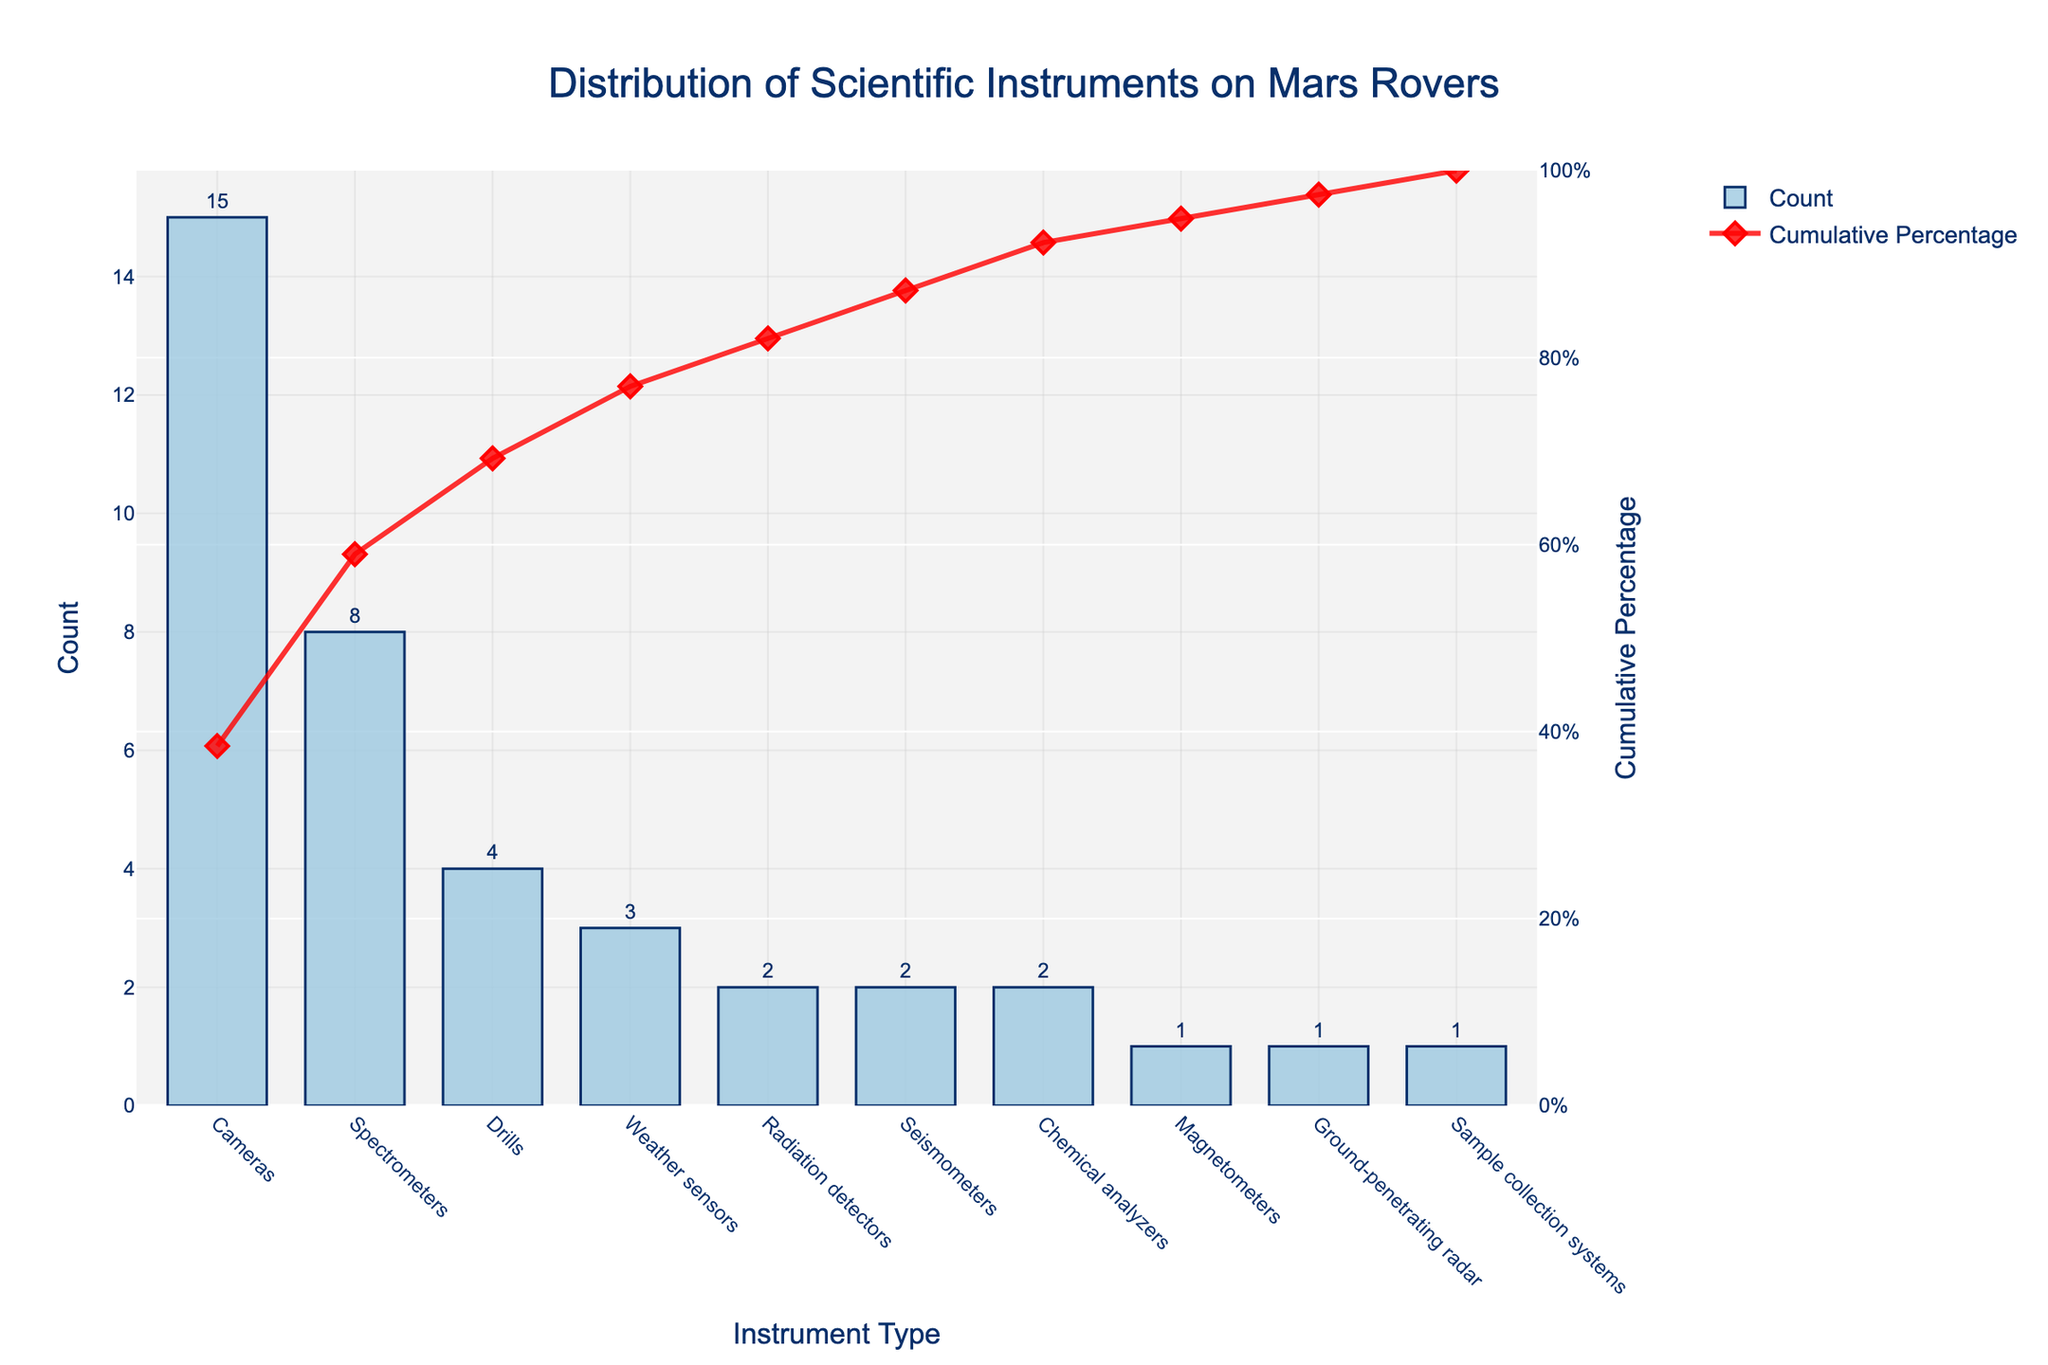1. What is the title of the Pareto chart? Look at the main header text at the top of the chart, which describes the overall content.
Answer: Distribution of Scientific Instruments on Mars Rovers 2. Which instrument type appears most frequently on Mars rovers? Observe the tallest bar in the bar chart to identify the instrument with the highest count.
Answer: Cameras 3. What is the count for spectrometers? Check the height of the bar corresponding to spectrometers and read the value indicated.
Answer: 8 4. What is the cumulative percentage for weather sensors? Find the point on the red cumulative percentage line corresponding to weather sensors and read the value from the secondary y-axis.
Answer: 80% 5. How many instruments are used less frequently than drills? Identify all instruments with counts less than that of drills, which have a count of 4. Count these instruments.
Answer: 5 6. Which is more common, radiation detectors or seismometers? Compare the heights of the bars for radiation detectors and seismometers and note which has a higher value.
Answer: Radiation detectors 7. What is the total count of all instruments used on Mars rovers described in the chart? Sum all the counts of the instruments as provided: 15 + 8 + 4 + 3 + 2 + 2 + 2 + 1 + 1 + 1
Answer: 39 8. What percentage of the total do the four most common instruments represent? Find the cumulative percentage at the fourth most common instrument (weather sensors), as shown by the red line ending at that point.
Answer: 80% 9. How many instruments are required to reach a cumulative percentage of at least 90%? Trace the cumulative percentage line until it reaches or exceeds 90% and count the number of instruments up to that point.
Answer: 6 10. Which instrument is depicted by a red diamond marker at approximately 95% cumulative percentage? Identify the instrument directly below the red diamond marker near the 95% line on the secondary y-axis.
Answer: Chemical analyzers 